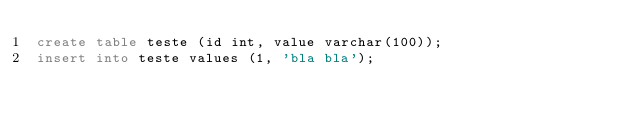<code> <loc_0><loc_0><loc_500><loc_500><_SQL_>create table teste (id int, value varchar(100));
insert into teste values (1, 'bla bla');

</code> 